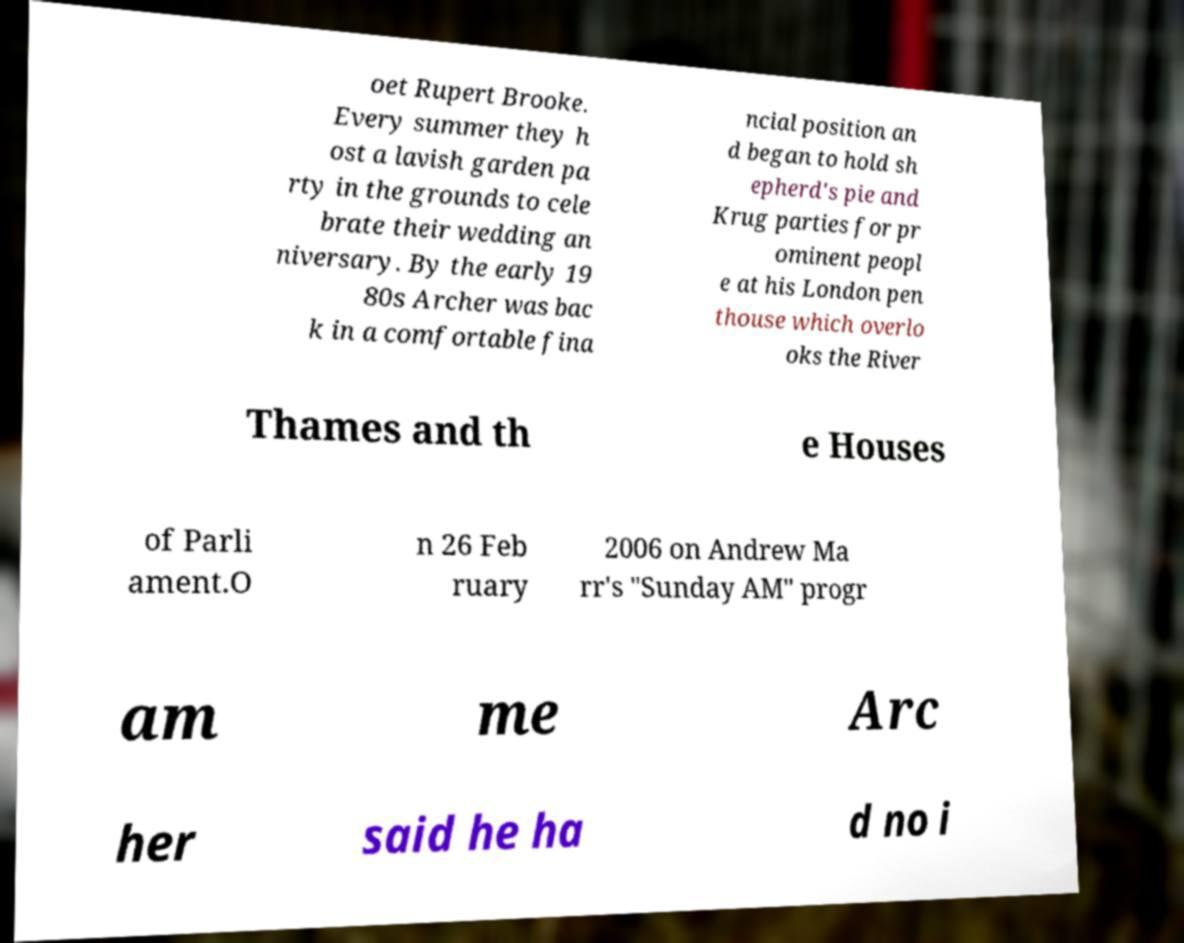I need the written content from this picture converted into text. Can you do that? oet Rupert Brooke. Every summer they h ost a lavish garden pa rty in the grounds to cele brate their wedding an niversary. By the early 19 80s Archer was bac k in a comfortable fina ncial position an d began to hold sh epherd's pie and Krug parties for pr ominent peopl e at his London pen thouse which overlo oks the River Thames and th e Houses of Parli ament.O n 26 Feb ruary 2006 on Andrew Ma rr's "Sunday AM" progr am me Arc her said he ha d no i 